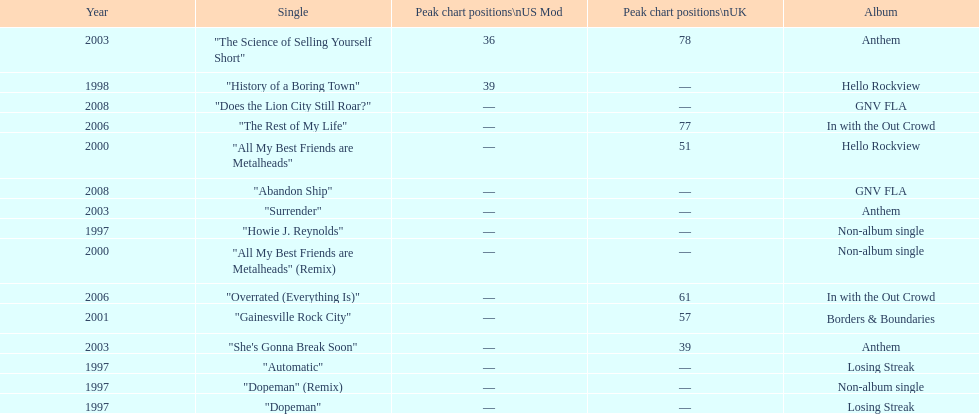Compare the chart positions between the us and the uk for the science of selling yourself short, where did it do better? US. 